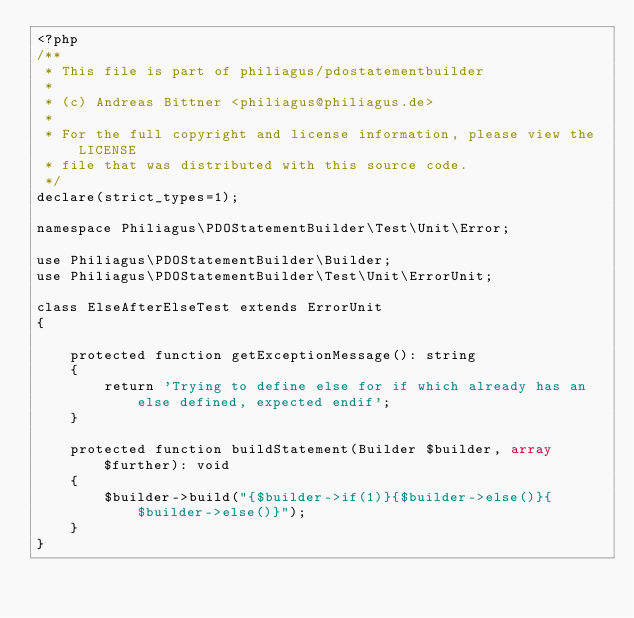Convert code to text. <code><loc_0><loc_0><loc_500><loc_500><_PHP_><?php
/**
 * This file is part of philiagus/pdostatementbuilder
 *
 * (c) Andreas Bittner <philiagus@philiagus.de>
 *
 * For the full copyright and license information, please view the LICENSE
 * file that was distributed with this source code.
 */
declare(strict_types=1);

namespace Philiagus\PDOStatementBuilder\Test\Unit\Error;

use Philiagus\PDOStatementBuilder\Builder;
use Philiagus\PDOStatementBuilder\Test\Unit\ErrorUnit;

class ElseAfterElseTest extends ErrorUnit
{

    protected function getExceptionMessage(): string
    {
        return 'Trying to define else for if which already has an else defined, expected endif';
    }

    protected function buildStatement(Builder $builder, array $further): void
    {
        $builder->build("{$builder->if(1)}{$builder->else()}{$builder->else()}");
    }
}</code> 